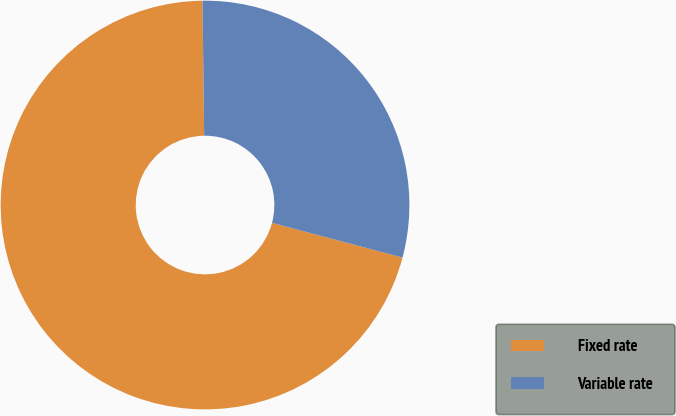<chart> <loc_0><loc_0><loc_500><loc_500><pie_chart><fcel>Fixed rate<fcel>Variable rate<nl><fcel>70.66%<fcel>29.34%<nl></chart> 